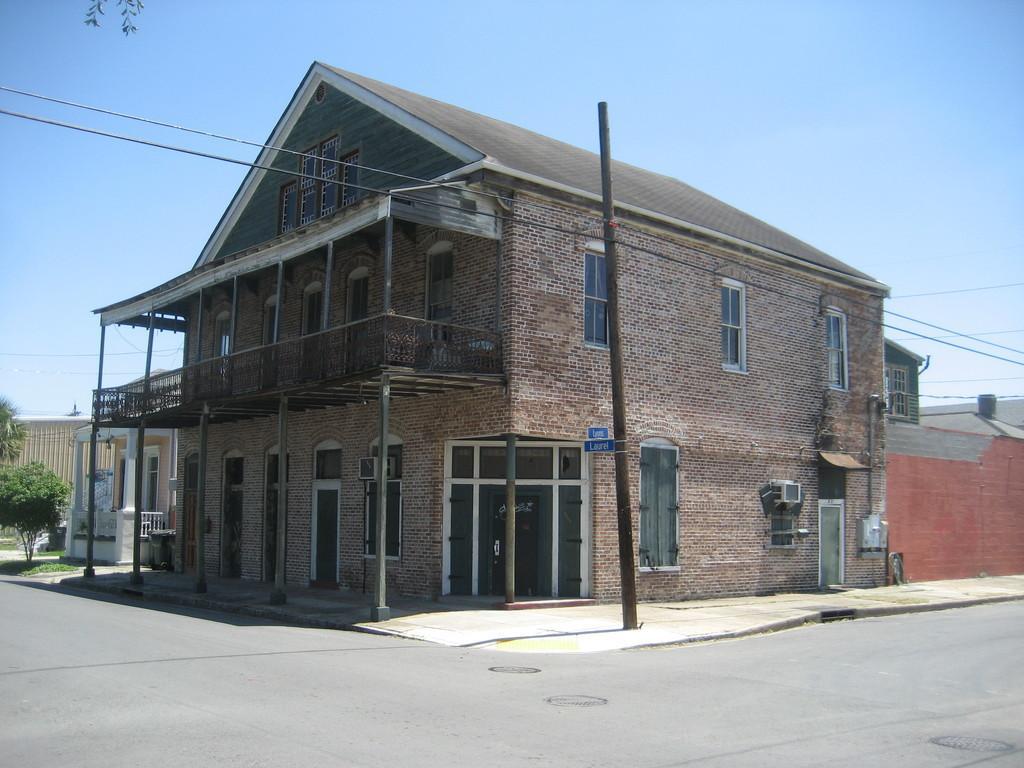In one or two sentences, can you explain what this image depicts? In this picture there is a big house and a pole in the center of the image and there are plants on the left side of the image. 